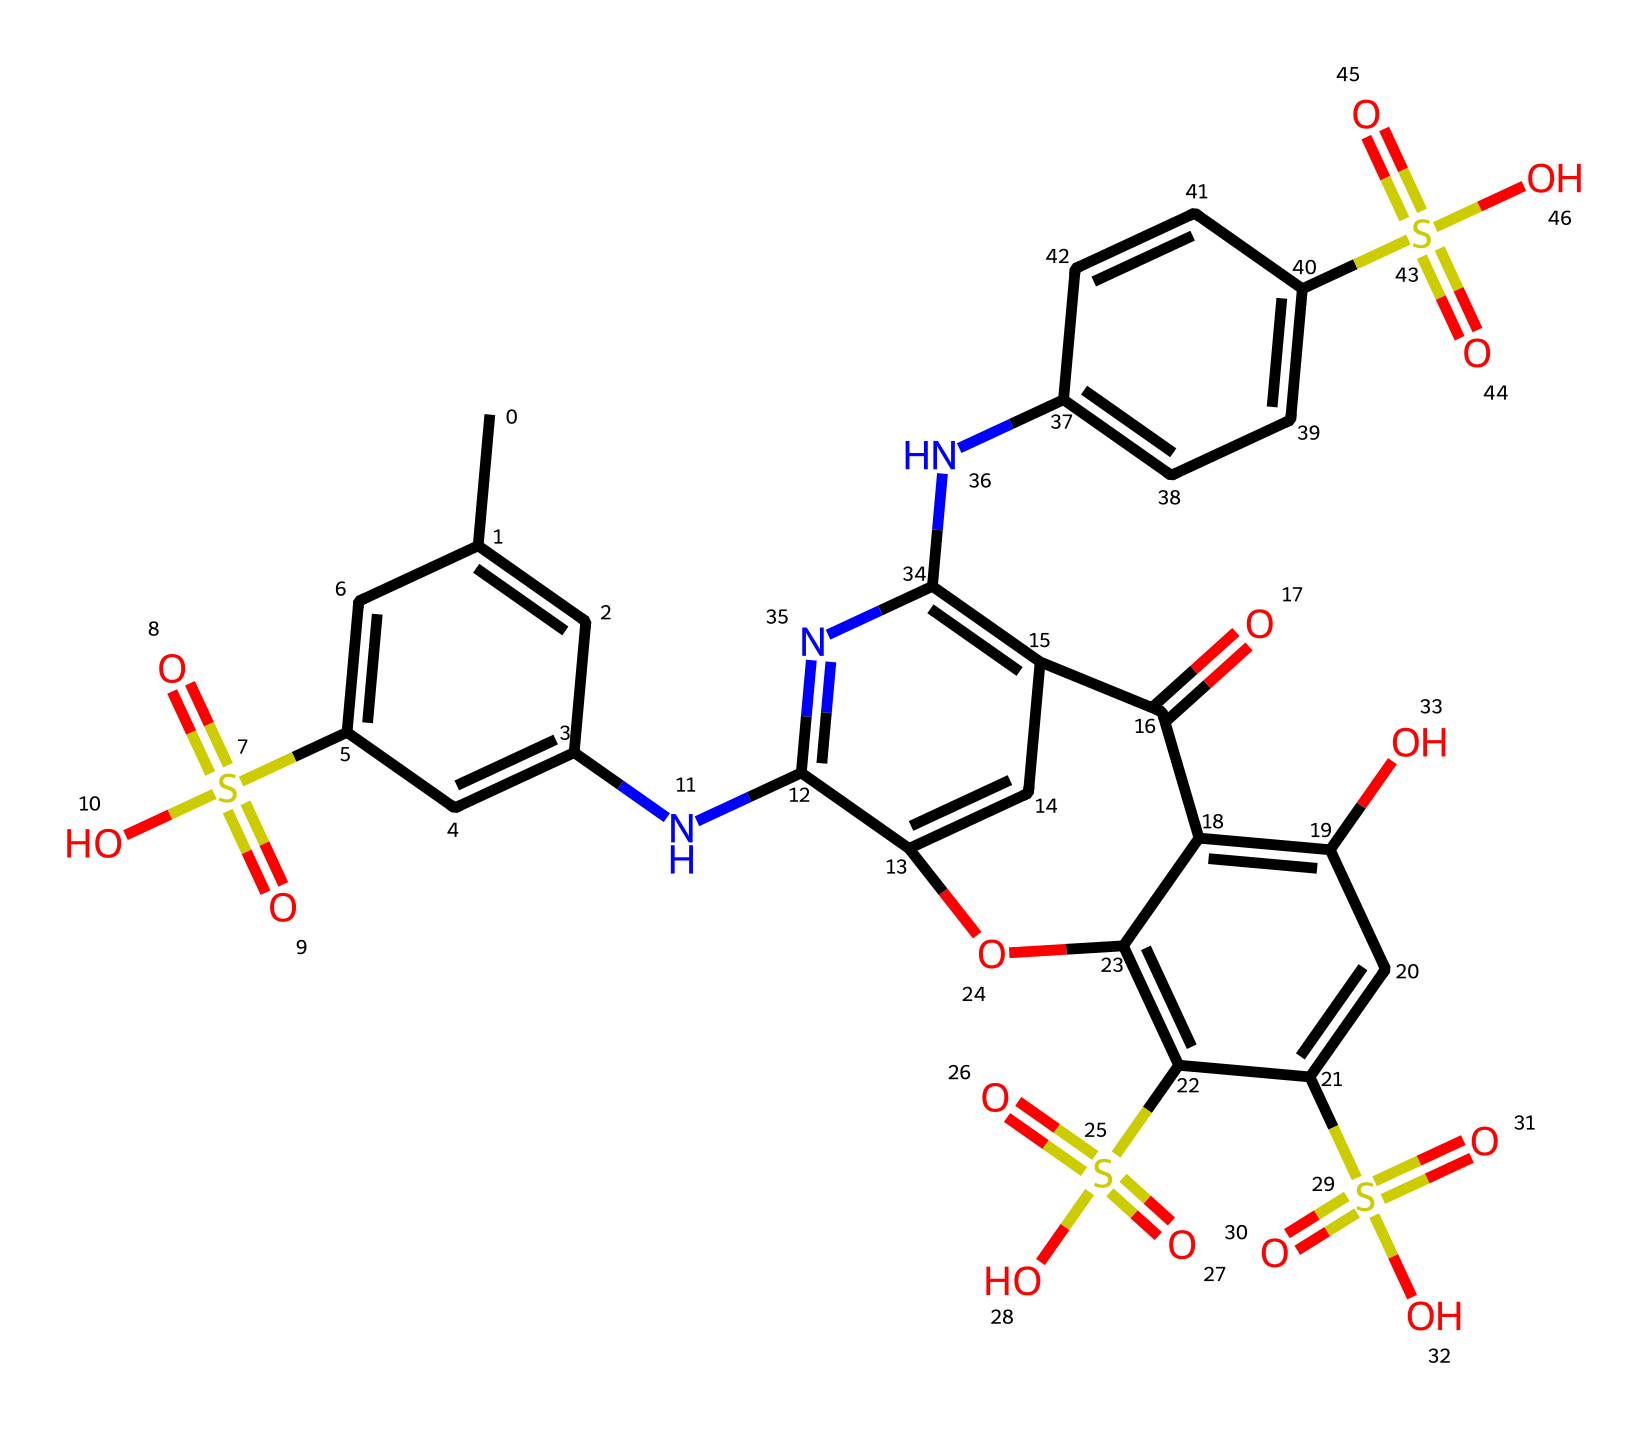What is the total number of sulfur atoms in the molecular structure? By examining the SMILES representation, you can identify sulfur atoms represented by the letter 'S'. In this structure, there are three occurrences of 'S', indicating the presence of three sulfur atoms.
Answer: 3 How many nitrogen atoms are present in the dye's structure? In the SMILES representation, nitrogen atoms are denoted by 'N'. Counting these, we find there are four occurrences of 'N' throughout the molecule.
Answer: 4 What functional groups can be identified in this compound? Analyzing the structure reveals the presence of sulfonic acid groups (S(=O)(=O)O), amino groups (NH), and hydroxyl groups (OH). These represent the functional groups present in the dye.
Answer: sulfonic acid, amino, hydroxyl Is the reactive blue 19 likely to be water-soluble? The presence of multiple sulfonic acid and hydroxyl groups usually enhances the water solubility of compounds. Since this dye has several such groups, it is reasonable to conclude that it is water-soluble.
Answer: yes Which chemical property is likely enhanced by the presence of sulfonic acid groups? Sulfonic acid groups generally enhance the ionic character of a compound, which in turn can increase the compound's solubility in water and biological fluids. In this case, that property is solubility.
Answer: solubility Is there a chromophore in the molecular structure? A chromophore is a part of a molecule responsible for its color, often containing conjugated double bonds or aromatic systems. In this case, the presence of multiple conjugated rings in the chemical structure suggests there is indeed a chromophore present.
Answer: yes 